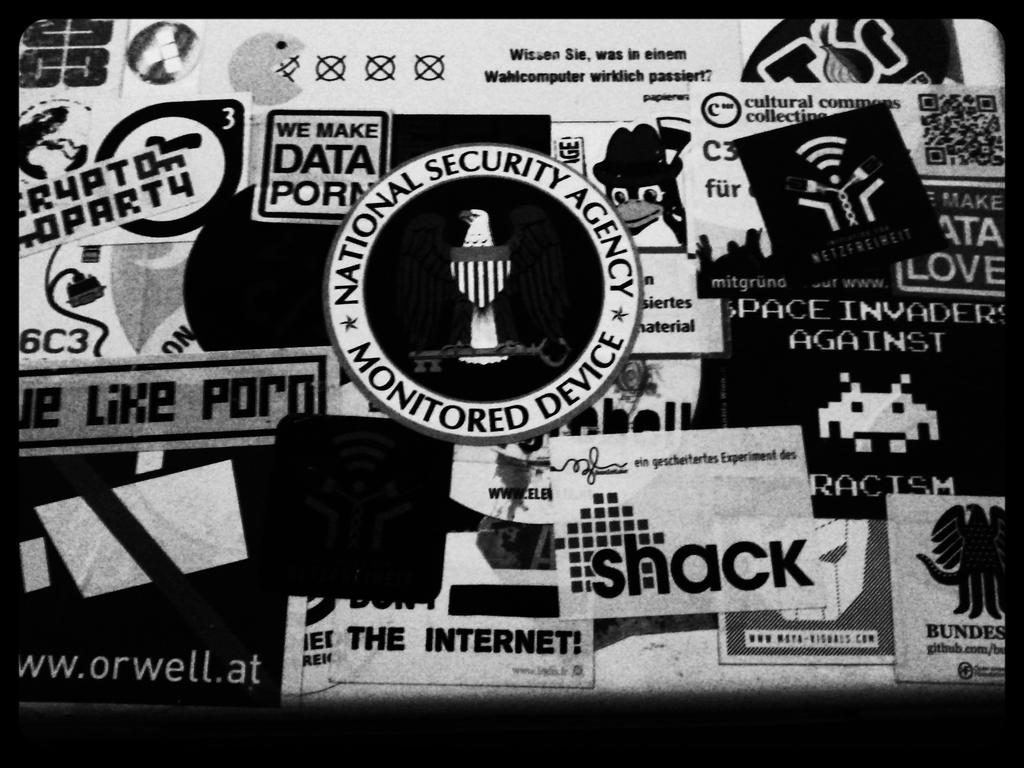What type of visual is the image? The image appears to be a poster. What can be found on the poster besides the symbol? There is text on the poster. What is the color scheme of the poster? The image is black and white. What flavor of bean is depicted in the image? There is no bean present in the image, and therefore no flavor can be determined. What form does the text on the poster take? The provided facts do not specify the form of the text on the poster, so we cannot definitively answer this question. 